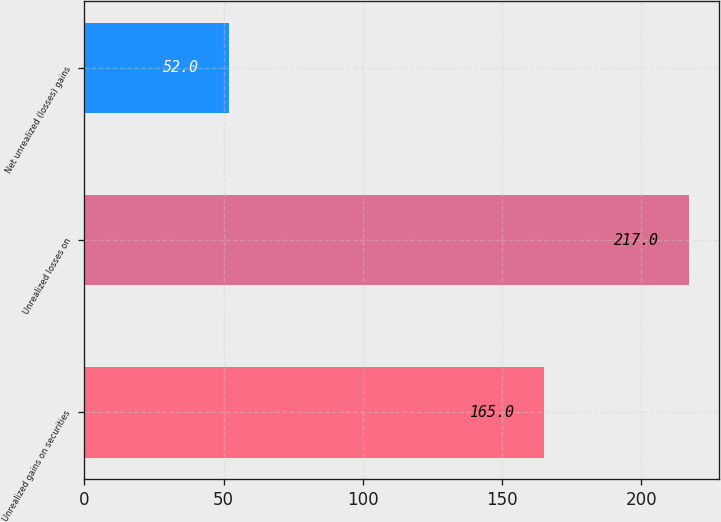Convert chart. <chart><loc_0><loc_0><loc_500><loc_500><bar_chart><fcel>Unrealized gains on securities<fcel>Unrealized losses on<fcel>Net unrealized (losses) gains<nl><fcel>165<fcel>217<fcel>52<nl></chart> 